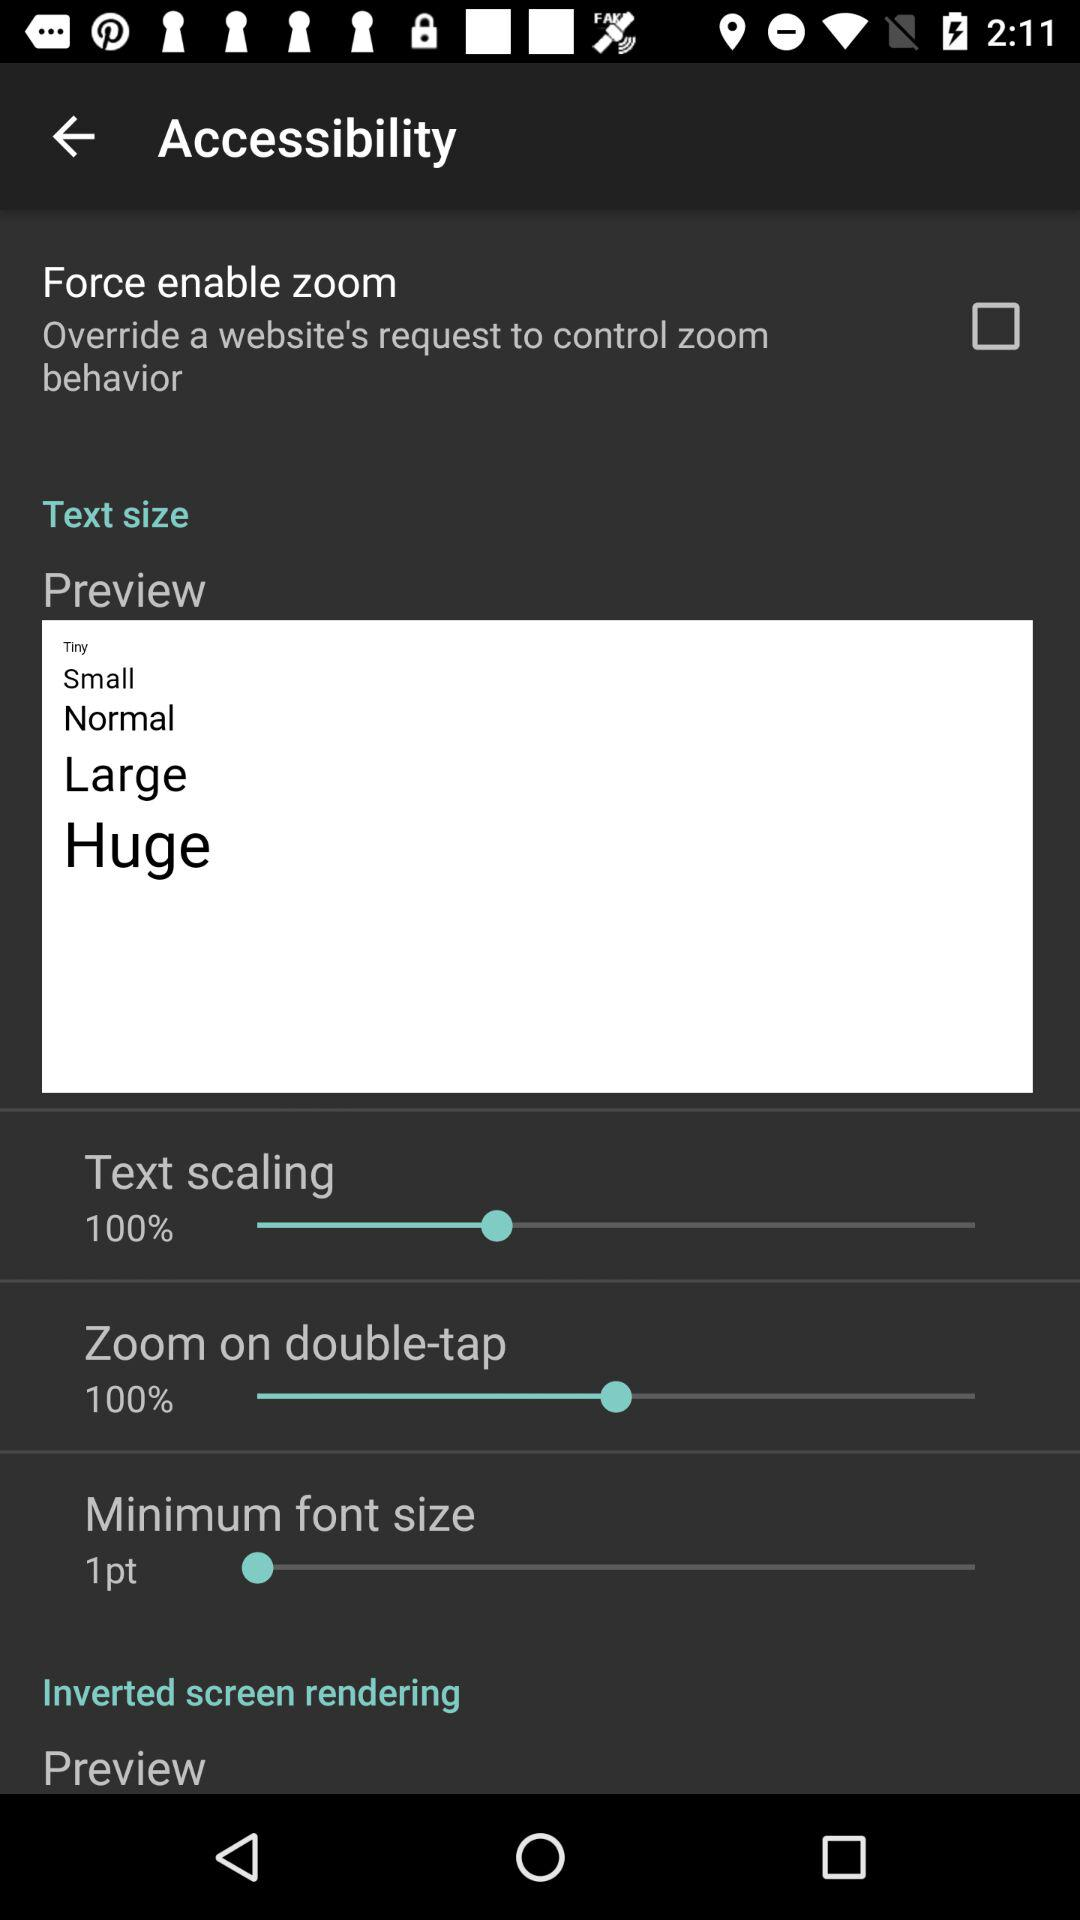What is the selected percentage for zoom on double-tap? The selected percentage for zoom on double-tap is 100. 